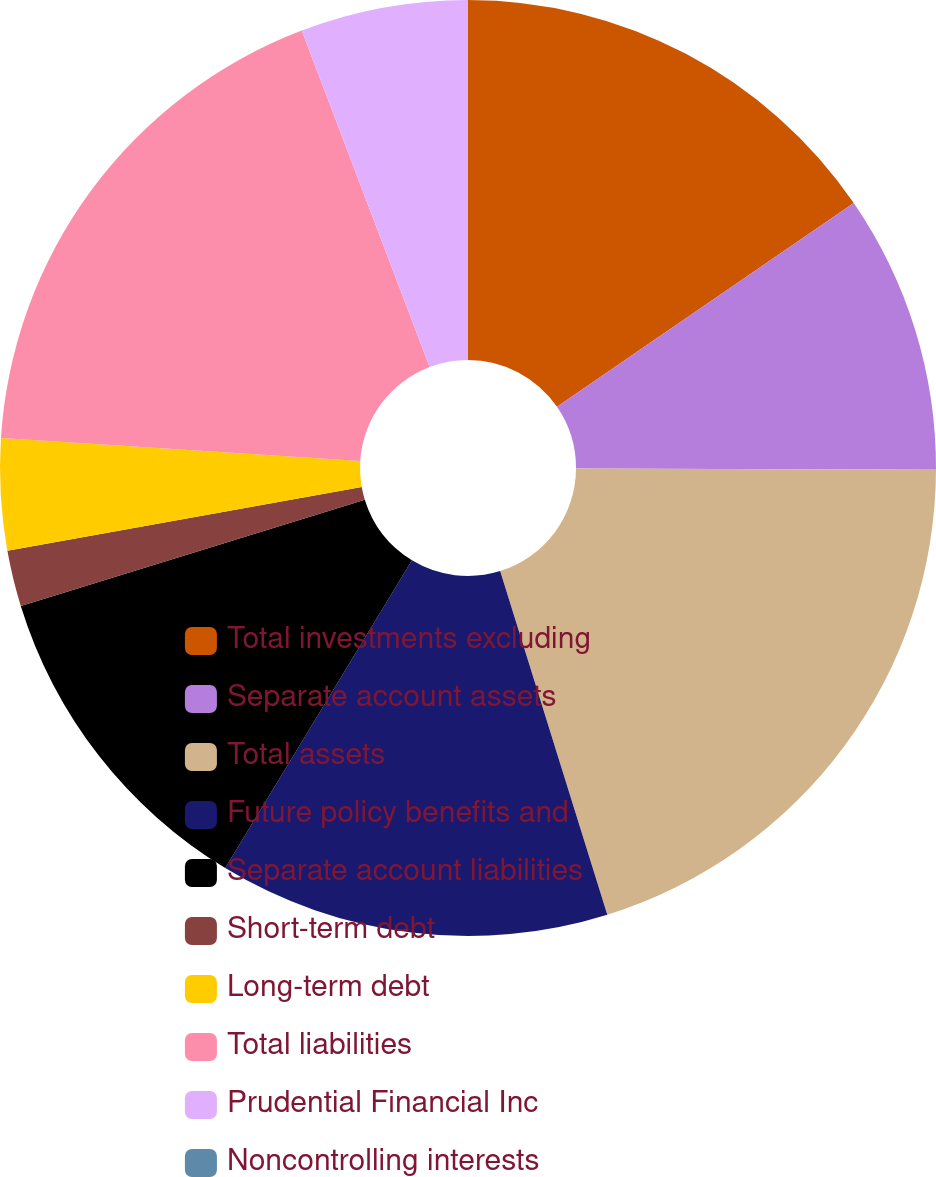Convert chart. <chart><loc_0><loc_0><loc_500><loc_500><pie_chart><fcel>Total investments excluding<fcel>Separate account assets<fcel>Total assets<fcel>Future policy benefits and<fcel>Separate account liabilities<fcel>Short-term debt<fcel>Long-term debt<fcel>Total liabilities<fcel>Prudential Financial Inc<fcel>Noncontrolling interests<nl><fcel>15.42%<fcel>9.64%<fcel>20.13%<fcel>13.49%<fcel>11.56%<fcel>1.93%<fcel>3.85%<fcel>18.2%<fcel>5.78%<fcel>0.0%<nl></chart> 